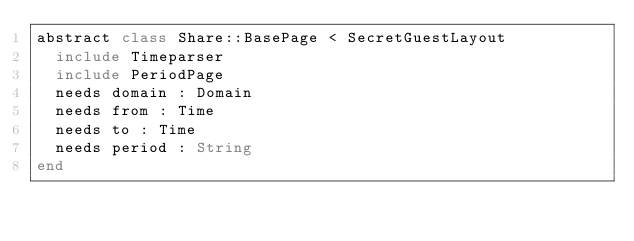<code> <loc_0><loc_0><loc_500><loc_500><_Crystal_>abstract class Share::BasePage < SecretGuestLayout
  include Timeparser
  include PeriodPage
  needs domain : Domain
  needs from : Time
  needs to : Time
  needs period : String
end
</code> 